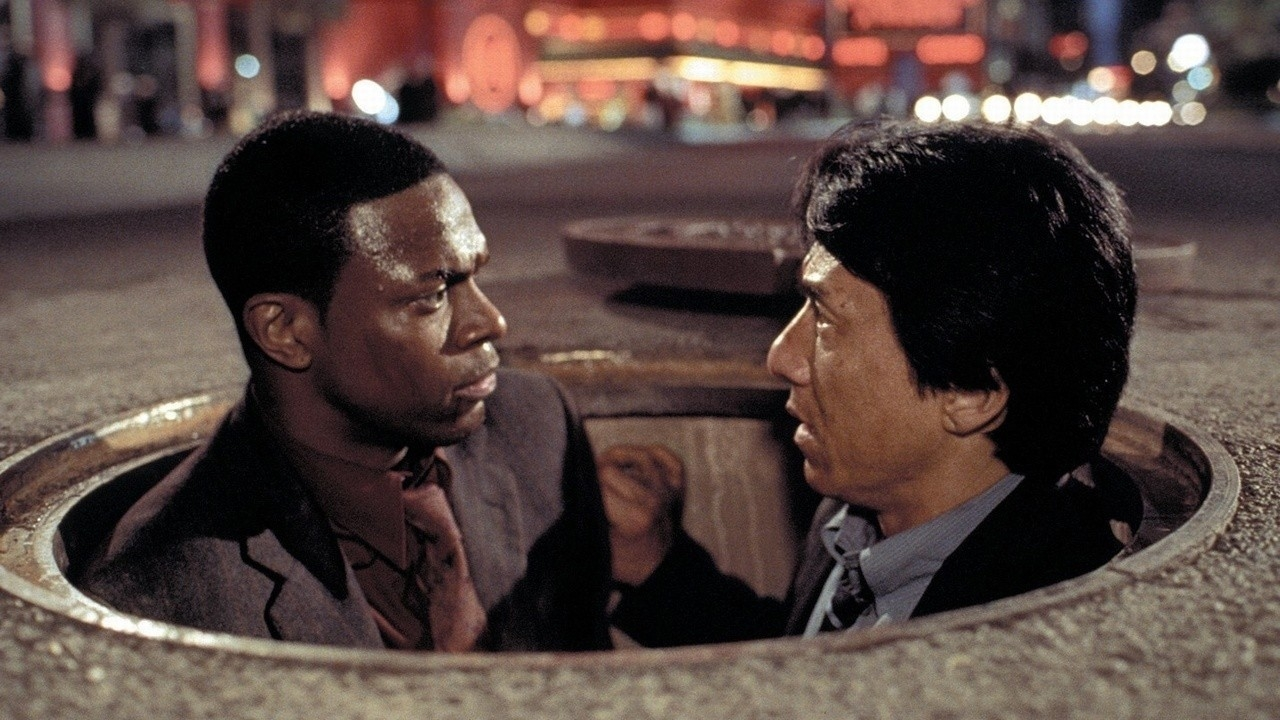Describe a scenario where these characters find themselves in a similar situation but for a completely different reason. In a completely different scenario, Chris Tucker and Jackie Chan's characters could be undercover reporters investigating a series of illegal underground poker games run by a notorious gang. Disguised as players, they somehow end up in the sewers after being discovered. The sharegpt4v/same serious expressions on their faces are now not only from the danger but also from the sudden realization that they’ve stumbled upon something much bigger than just gambling – a large network involved in human trafficking. They need to quickly come up with a plan to escape and inform the authorities, all while being pursued by the gang members who are hot on their trail. 